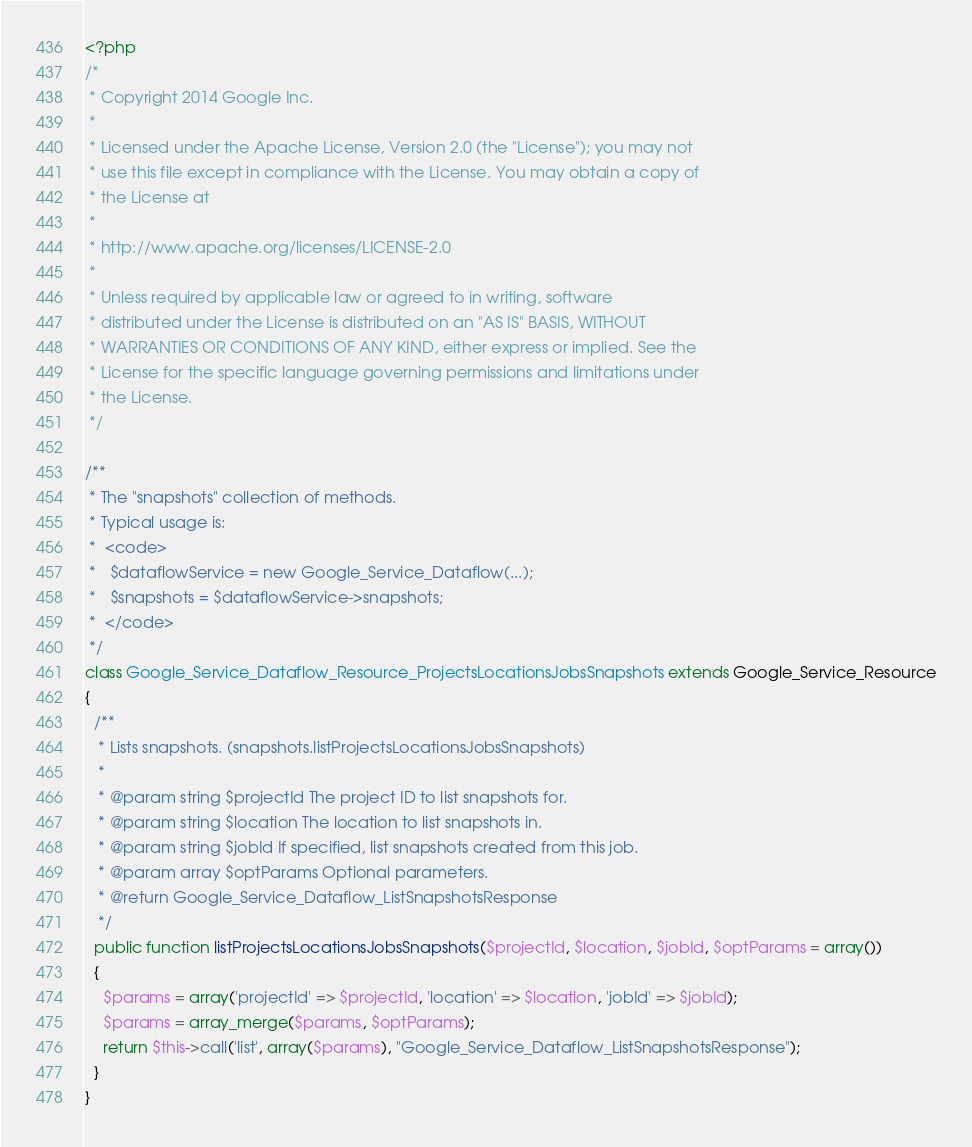Convert code to text. <code><loc_0><loc_0><loc_500><loc_500><_PHP_><?php
/*
 * Copyright 2014 Google Inc.
 *
 * Licensed under the Apache License, Version 2.0 (the "License"); you may not
 * use this file except in compliance with the License. You may obtain a copy of
 * the License at
 *
 * http://www.apache.org/licenses/LICENSE-2.0
 *
 * Unless required by applicable law or agreed to in writing, software
 * distributed under the License is distributed on an "AS IS" BASIS, WITHOUT
 * WARRANTIES OR CONDITIONS OF ANY KIND, either express or implied. See the
 * License for the specific language governing permissions and limitations under
 * the License.
 */

/**
 * The "snapshots" collection of methods.
 * Typical usage is:
 *  <code>
 *   $dataflowService = new Google_Service_Dataflow(...);
 *   $snapshots = $dataflowService->snapshots;
 *  </code>
 */
class Google_Service_Dataflow_Resource_ProjectsLocationsJobsSnapshots extends Google_Service_Resource
{
  /**
   * Lists snapshots. (snapshots.listProjectsLocationsJobsSnapshots)
   *
   * @param string $projectId The project ID to list snapshots for.
   * @param string $location The location to list snapshots in.
   * @param string $jobId If specified, list snapshots created from this job.
   * @param array $optParams Optional parameters.
   * @return Google_Service_Dataflow_ListSnapshotsResponse
   */
  public function listProjectsLocationsJobsSnapshots($projectId, $location, $jobId, $optParams = array())
  {
    $params = array('projectId' => $projectId, 'location' => $location, 'jobId' => $jobId);
    $params = array_merge($params, $optParams);
    return $this->call('list', array($params), "Google_Service_Dataflow_ListSnapshotsResponse");
  }
}
</code> 